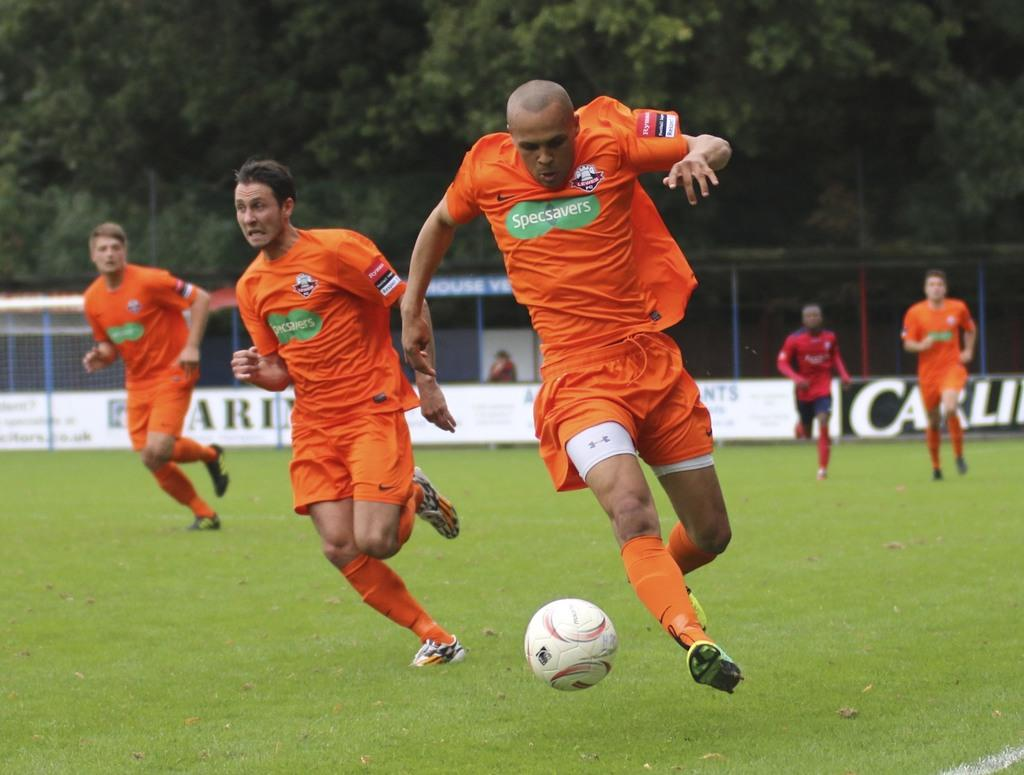What are the people in the image doing? The people in the image are running. What are the people wearing on their feet? The people are wearing shoes. What is the object in the image that the people might be playing with? There is a ball in the image. What type of surface can be seen in the image? There is grass in the image. What structure is present in the image that might be used for a game? There is a net in the image. What type of barrier is present in the image? There is a fence in the image. What type of vertical structures are present in the image? There are posts in the image. What type of natural vegetation is visible in the image? There are trees in the image. What type of food is being prepared on the grill in the image? There is no grill or food present in the image; it features people running with a ball and various structures in a grassy area. 